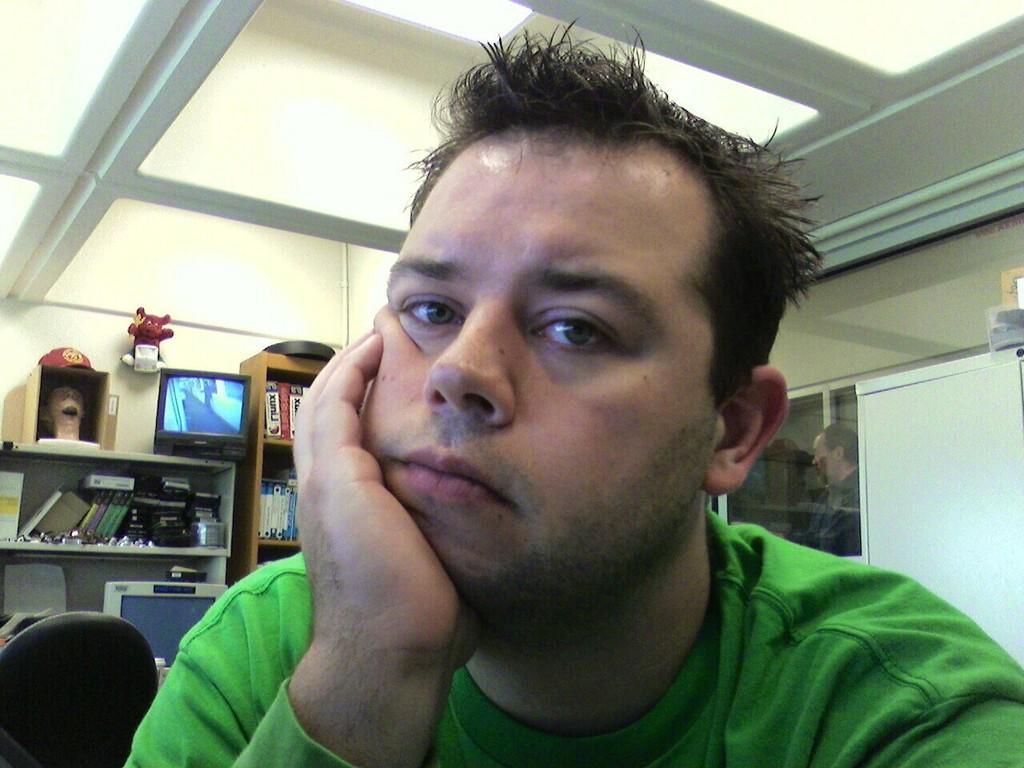How would you summarize this image in a sentence or two? In this image, I can see the man with a green T-shirt. This looks like a chair. Here is a television with the display. These are the books, toy and few other things. This looks like a monitor. I can see the books, which are placed in the bookshelf. This looks like a toy which is attached to the wall. I think this is a ceiling. In the background, that looks like a glass door. I can see a person standing. 